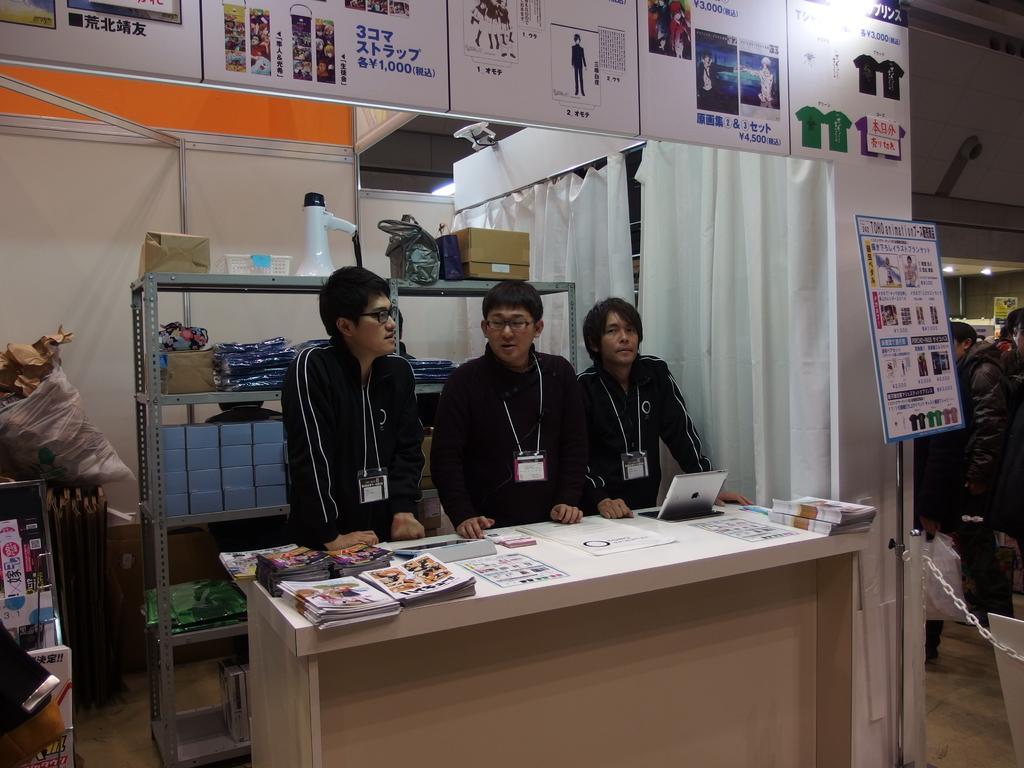Please provide a concise description of this image. Here we can see three people behind the desk wearing same uniform and the id cards. Among them two has spectacles and on the bench we have some papers and the laptop behind them there is a rack on which some things are placed and also we have the positions above them. 